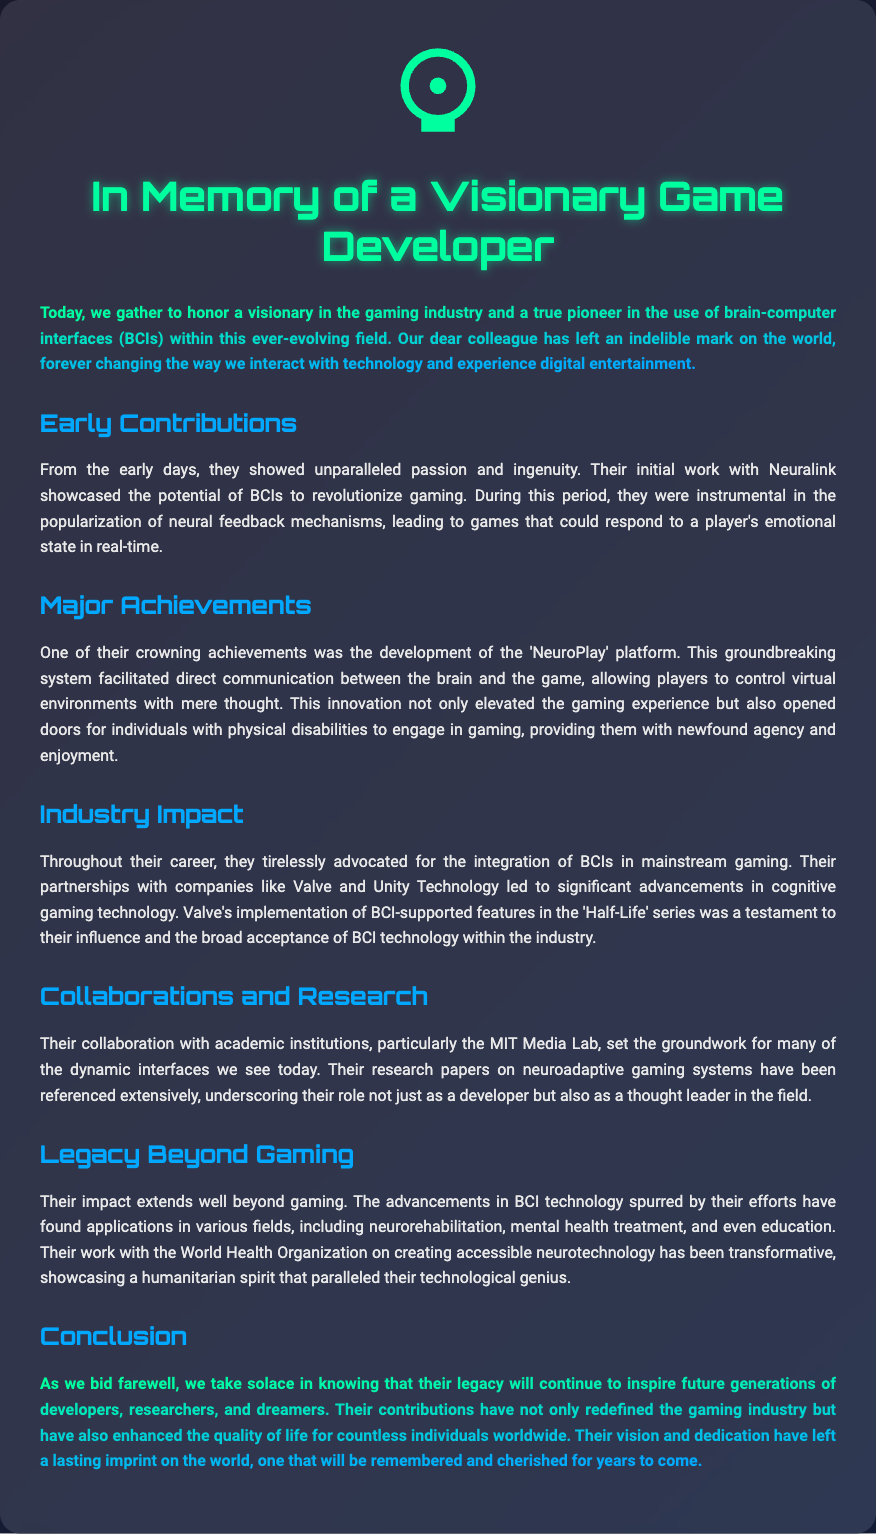What was the name of the groundbreaking system developed? The document states that the groundbreaking system was called 'NeuroPlay'.
Answer: NeuroPlay What did the individual showcase at Neuralink? The document mentions that they showcased the potential of BCIs to revolutionize gaming.
Answer: Potential of BCIs Which companies did the individual partner with? The document lists Valve and Unity Technology as companies they partnered with.
Answer: Valve and Unity Technology What aspect of the gaming industry did the individual advocate for? The individual tirelessly advocated for the integration of BCIs in mainstream gaming.
Answer: Integration of BCIs What institution did the individual collaborate with on research? The document highlights their collaboration with the MIT Media Lab.
Answer: MIT Media Lab What significant feature was implemented in the 'Half-Life' series? The document states that Valve implemented BCI-supported features in the 'Half-Life' series.
Answer: BCI-supported features What humanitarian organization did the individual work with? The document mentions the World Health Organization as the humanitarian organization they worked with.
Answer: World Health Organization What was the main focus of their research papers? The focus of their research papers was on neuroadaptive gaming systems.
Answer: Neuroadaptive gaming systems What legacy did the individual leave for future generations? The document states that their contributions will continue to inspire future generations of developers, researchers, and dreamers.
Answer: Inspire future generations 